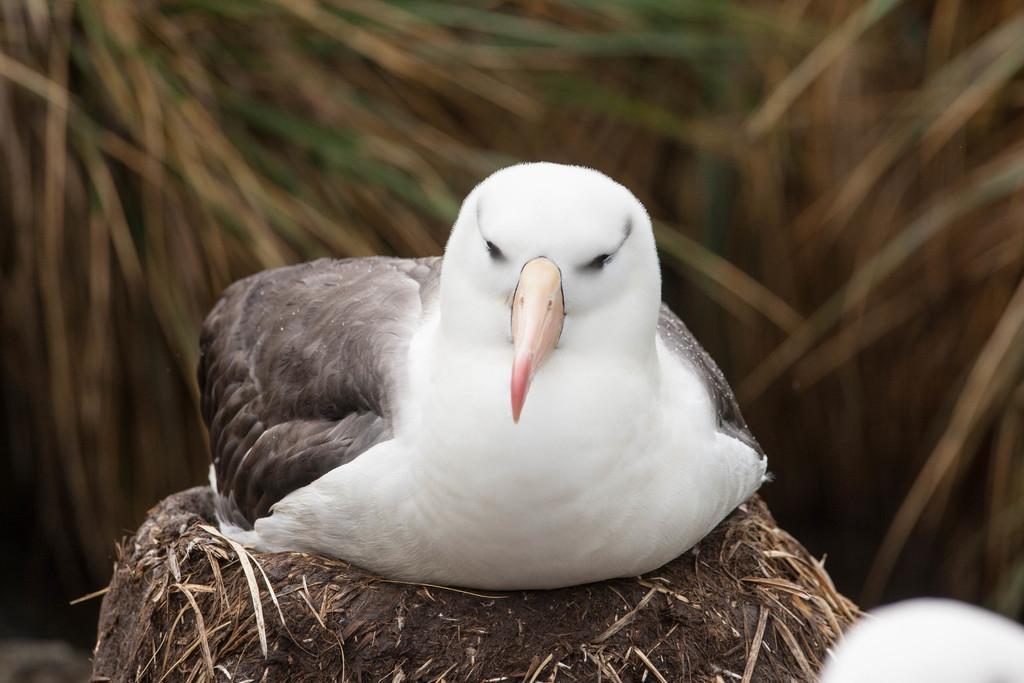In one or two sentences, can you explain what this image depicts? In the image there is a bird sitting on the nest. Behind the bird there is a blur background. 